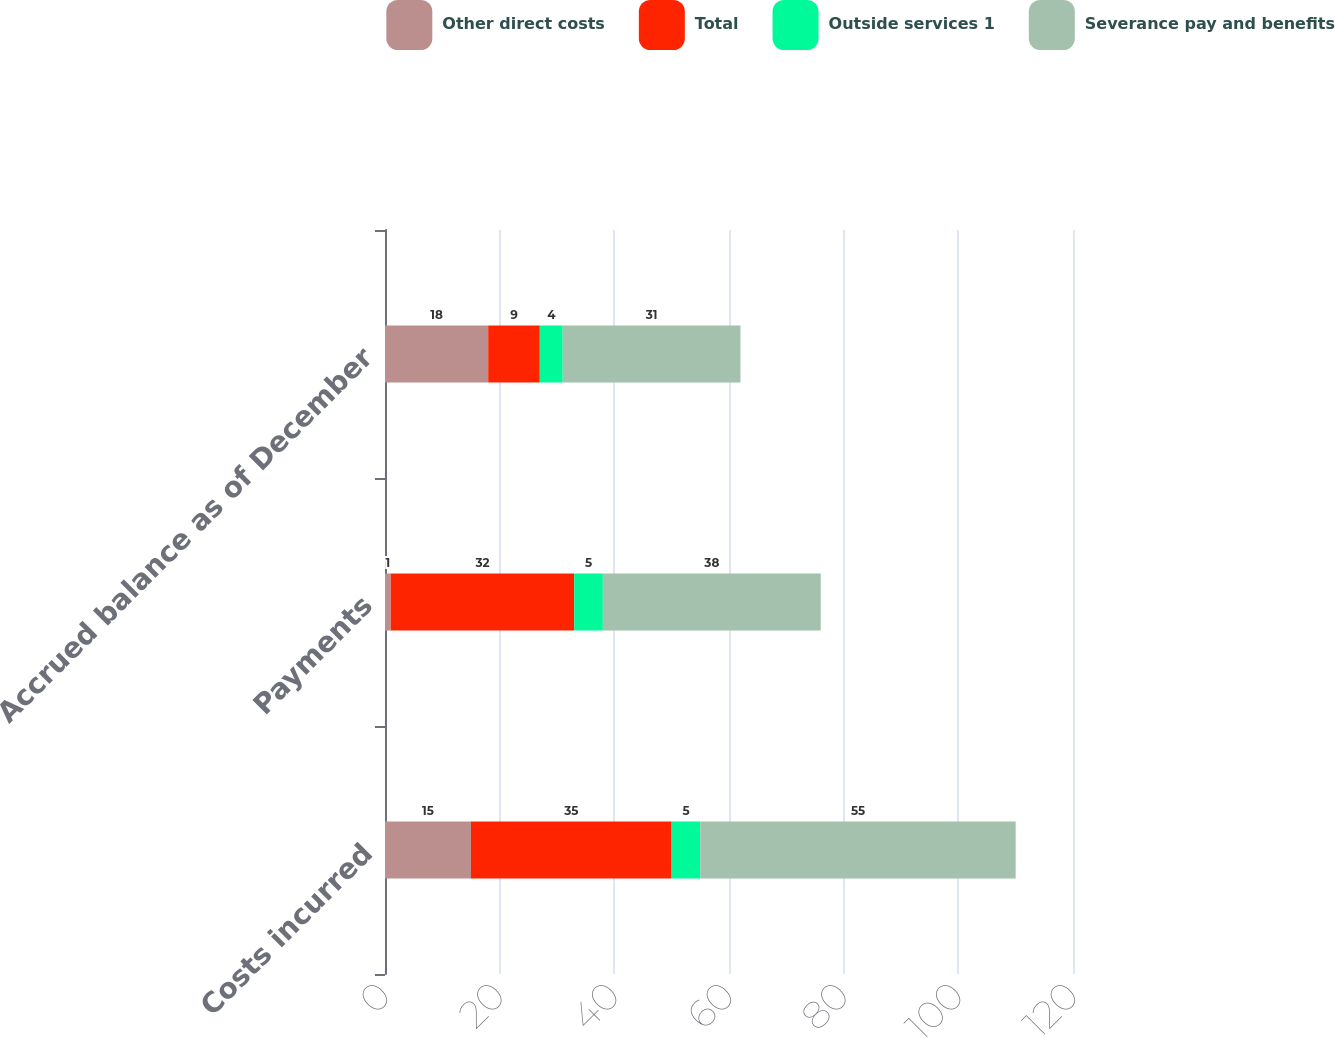Convert chart to OTSL. <chart><loc_0><loc_0><loc_500><loc_500><stacked_bar_chart><ecel><fcel>Costs incurred<fcel>Payments<fcel>Accrued balance as of December<nl><fcel>Other direct costs<fcel>15<fcel>1<fcel>18<nl><fcel>Total<fcel>35<fcel>32<fcel>9<nl><fcel>Outside services 1<fcel>5<fcel>5<fcel>4<nl><fcel>Severance pay and benefits<fcel>55<fcel>38<fcel>31<nl></chart> 